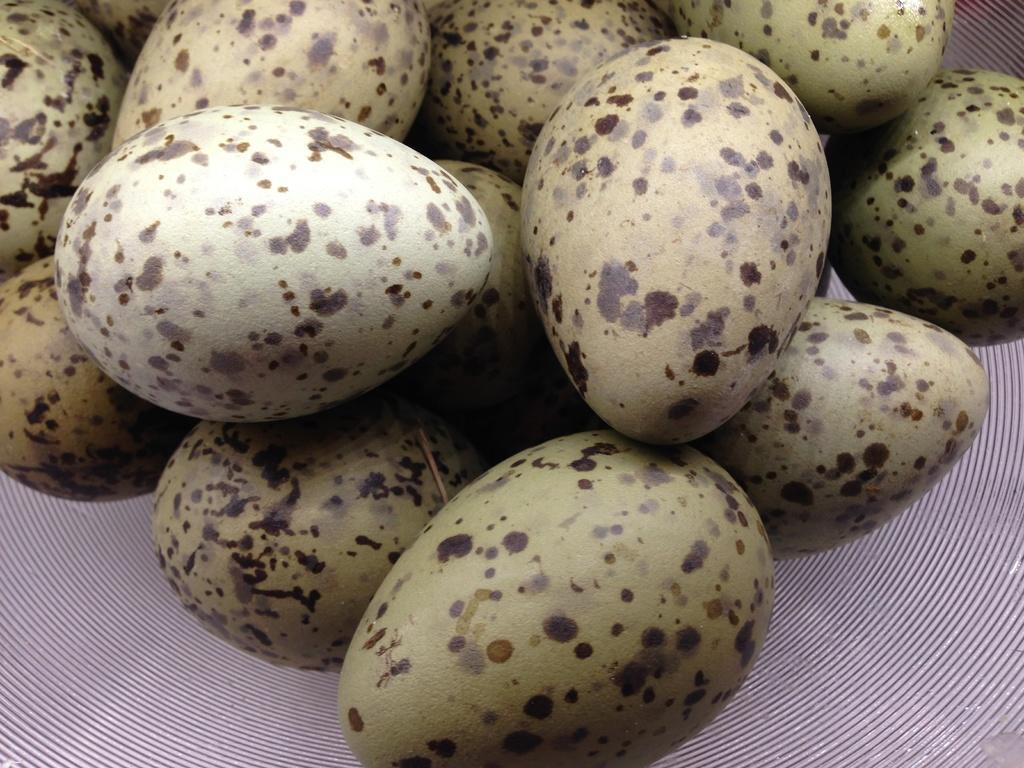Describe this image in one or two sentences. In the picture I can see eggs on a surface. On these eggs I can see black color spots. 